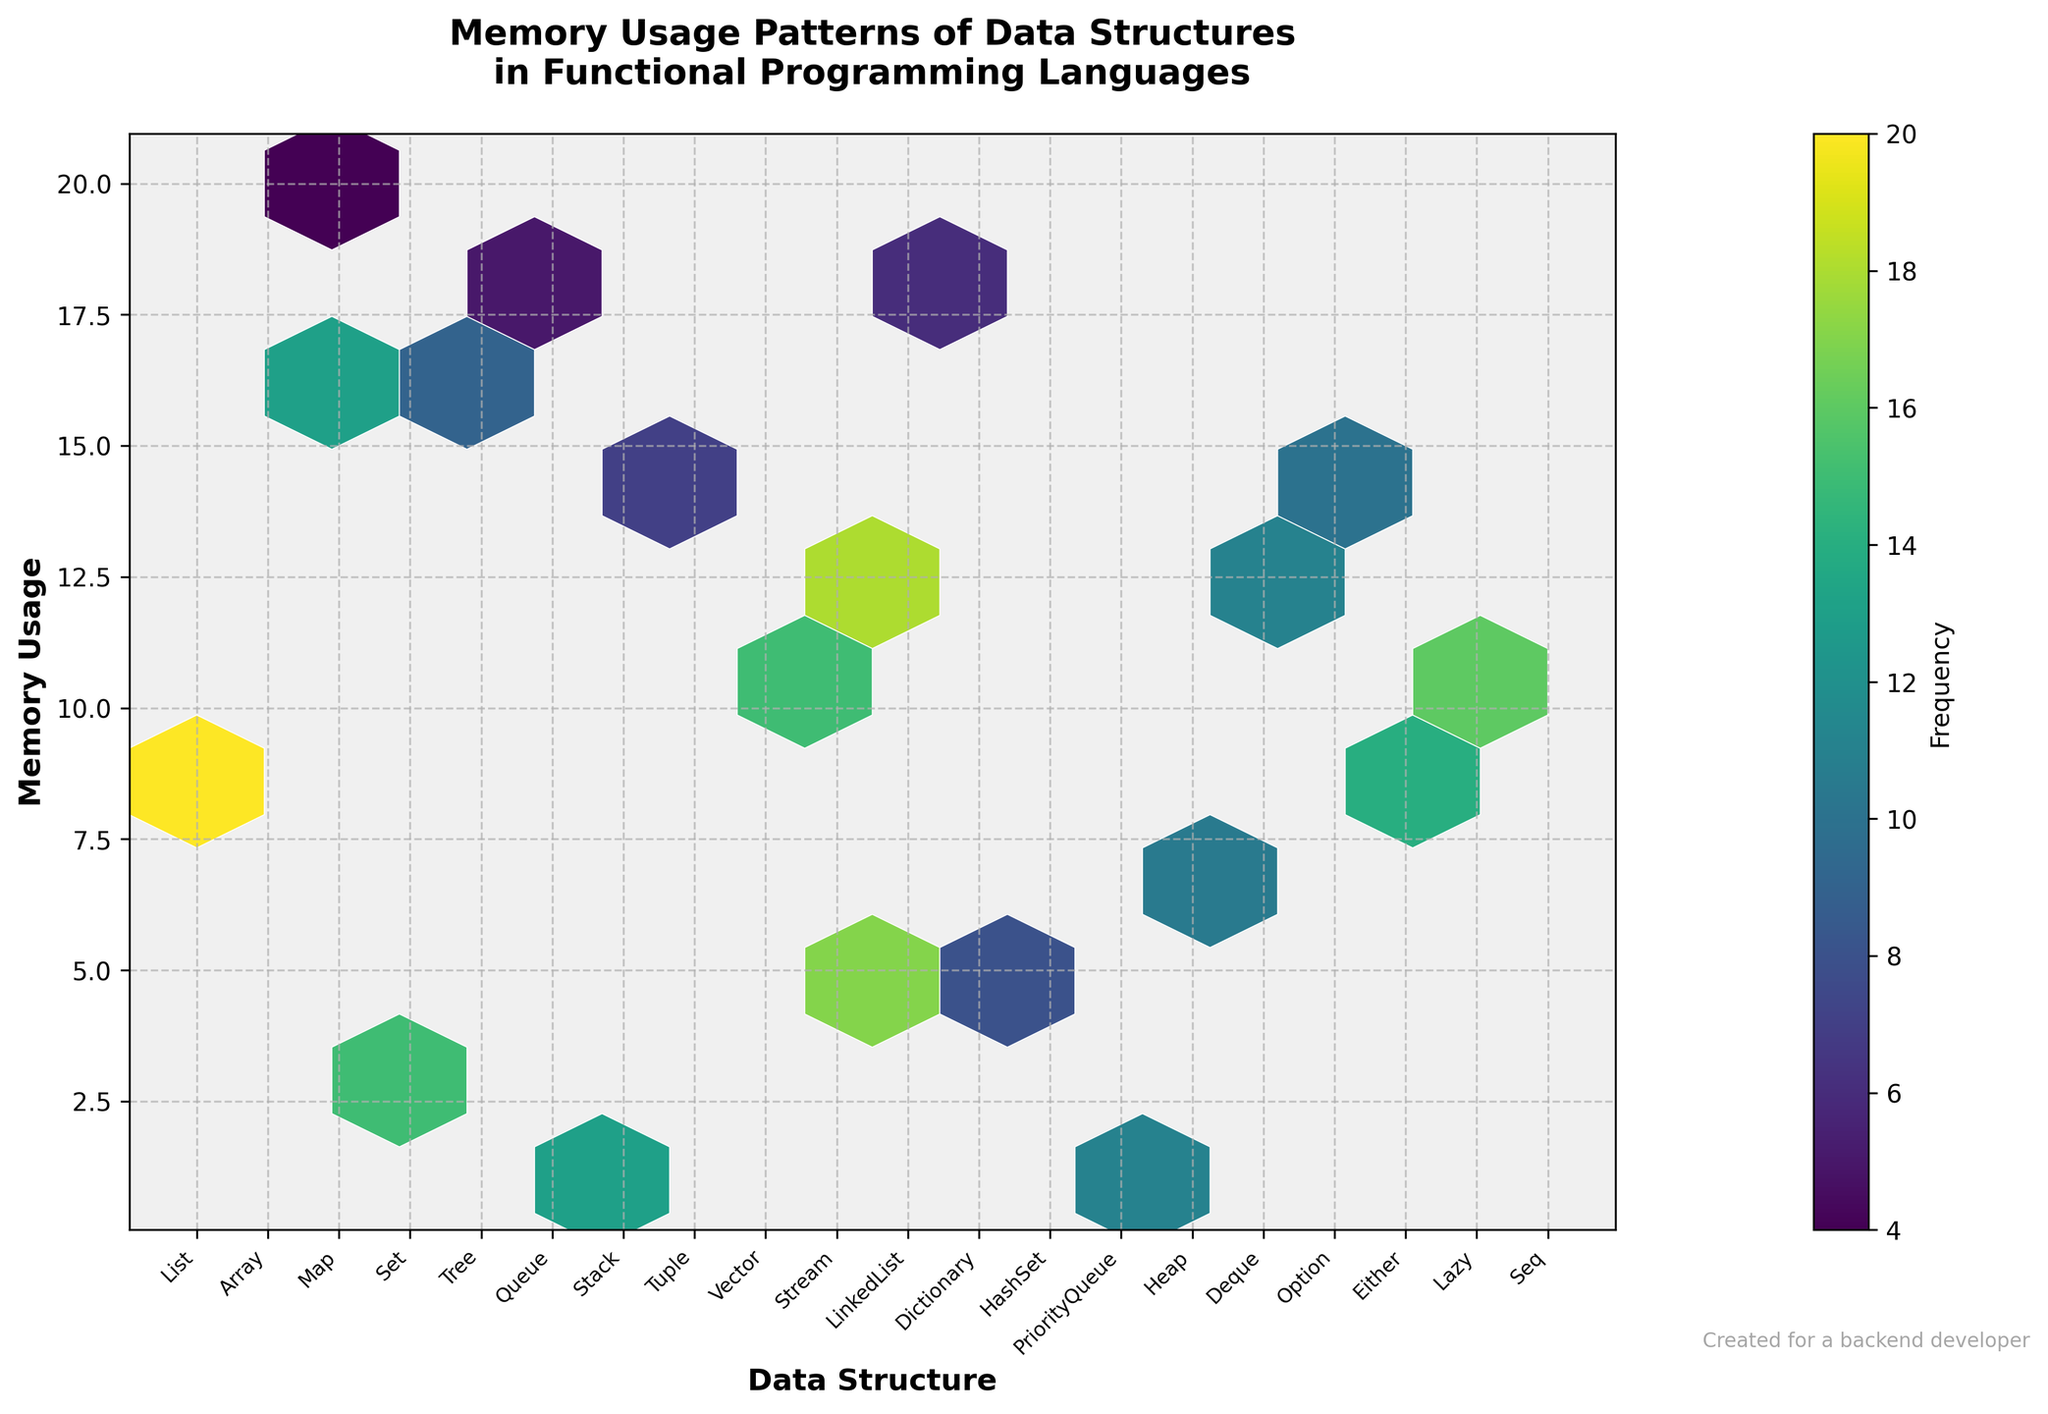what's the title of the plot? The title of the plot is typically located at the top center of the figure. It summarizes the content and purpose of the plot. The title of this plot is "Memory Usage Patterns of Data Structures in Functional Programming Languages."
Answer: Memory Usage Patterns of Data Structures in Functional Programming Languages how many data structures are represented in the plot? Count the number of unique labels on the x-axis, which are the names of different data structures. In this plot, each unique label corresponds to a data structure.
Answer: 20 which data structure has the highest memory usage? Look at the labels on the x-axis and find the one with the highest value on the y-axis. The label "Deque" corresponds to a memory usage of 20, which is the highest.
Answer: Deque what is the minimum value of memory usage depicted in the plot? Identify the smallest number on the y-axis. The minimum value depicted for memory usage in the plot is 1.
Answer: 1 what color scheme is used in the plot? The color scheme, or colormap, is visible in the hexagonal bins. The viridis colormap ranges from yellow to purple, representing different frequency levels.
Answer: viridis which data structure has the highest frequency within its corresponding memory usage range? Consult the color scale which indicates frequency and then find the data structure associated with the darkest hexagon. In this case, "Array" within its memory usage range (8) has the highest frequency.
Answer: Array what is the average memory usage of data structures with a frequency of 15? Identify the memory usage values associated with a frequency of 15. Sum these values and divide by the number of such instances. The memory usages with frequency 15 are 10, 10, and 3. Sum is 23, divided by 3 equals 7.67.
Answer: 7.67 which data structure shows the minimum frequency at its memory usage value? To identify the data structure with the minimum frequency, look for the lightest hexagon and refer to the corresponding data structure label on the x-axis. "PriorityQueue" at memory usage 18 has the lowest frequency of 6.
Answer: PriorityQueue are there more data structures with memory usage greater than 10 or less than 10? Count the data structures with memory usage values above 10 and those below. Data structures greater than 10 are 10 (Map, Tree, Tuple, Vector, Stream, LinkedList, Dictionary, HashSet, PriorityQueue, Heap, Deque), data structures less than 10 are 10 (Array, Set, Queue, Stack, Option, Either, Lazy, Seq, List).
Answer: equally distributed how does the grid size affect the hexbin plot visualization? Changing the grid size alters the number of hexagons displayed, affecting how dense or sparse the plot appears. Larger gridsize provides a more granular view, while a smaller gridsize shows higher level aggregates. This plot uses a gridsize of 10, balancing detail and readability.
Answer: Affects detail and readability 